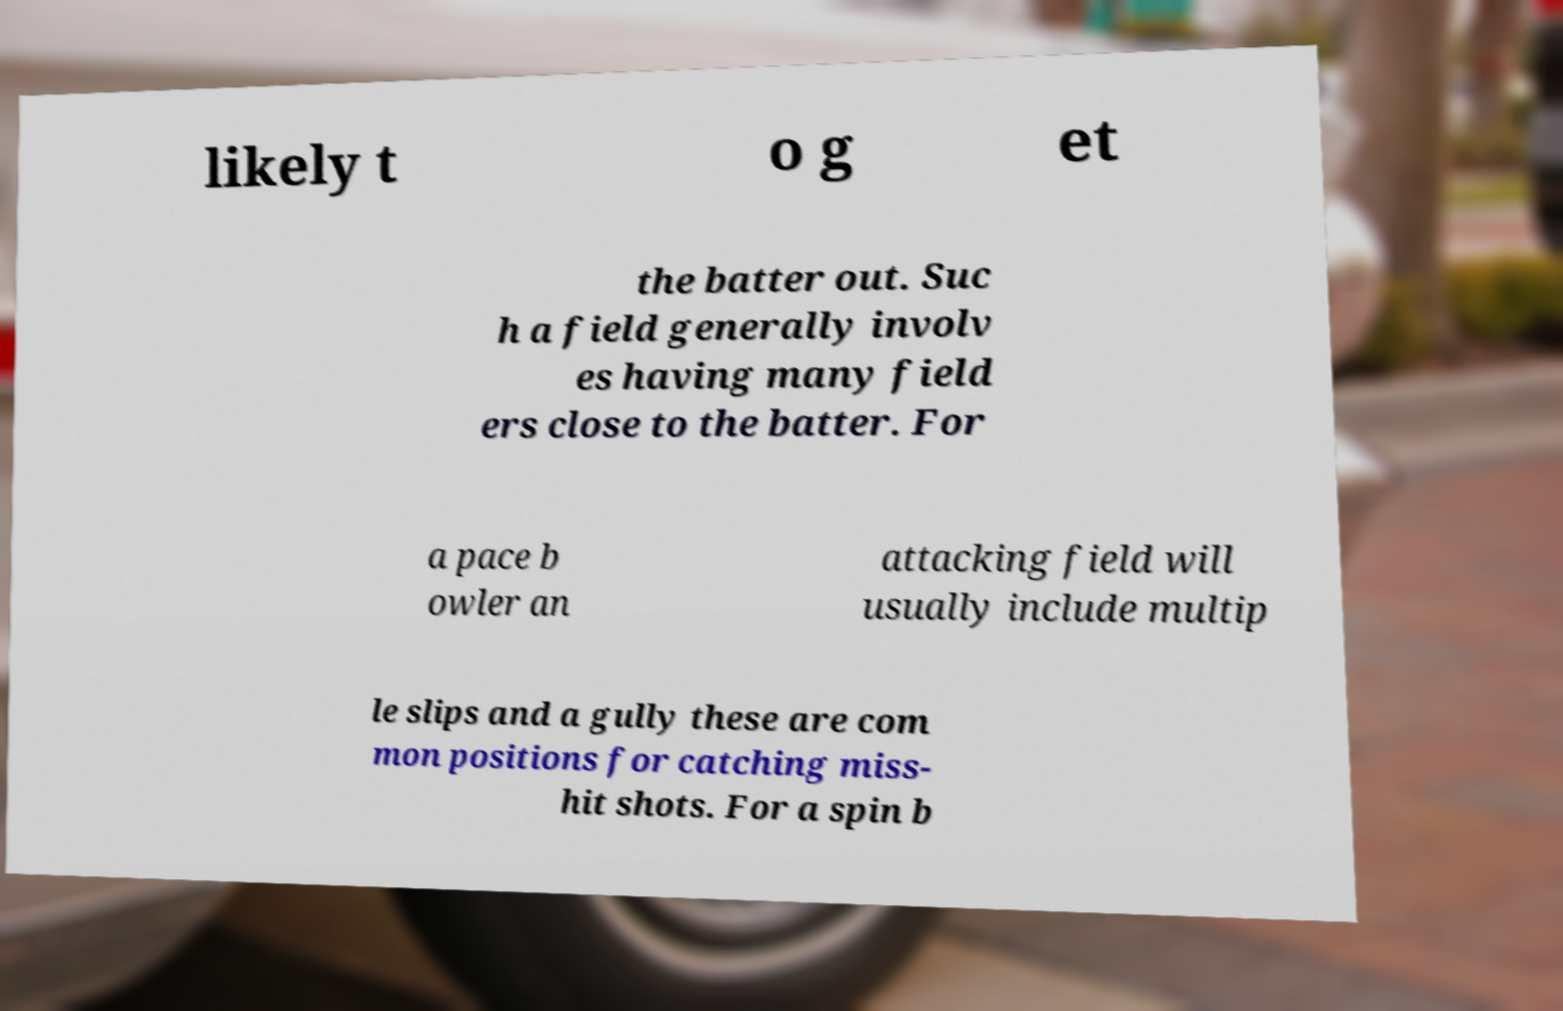Please read and relay the text visible in this image. What does it say? likely t o g et the batter out. Suc h a field generally involv es having many field ers close to the batter. For a pace b owler an attacking field will usually include multip le slips and a gully these are com mon positions for catching miss- hit shots. For a spin b 